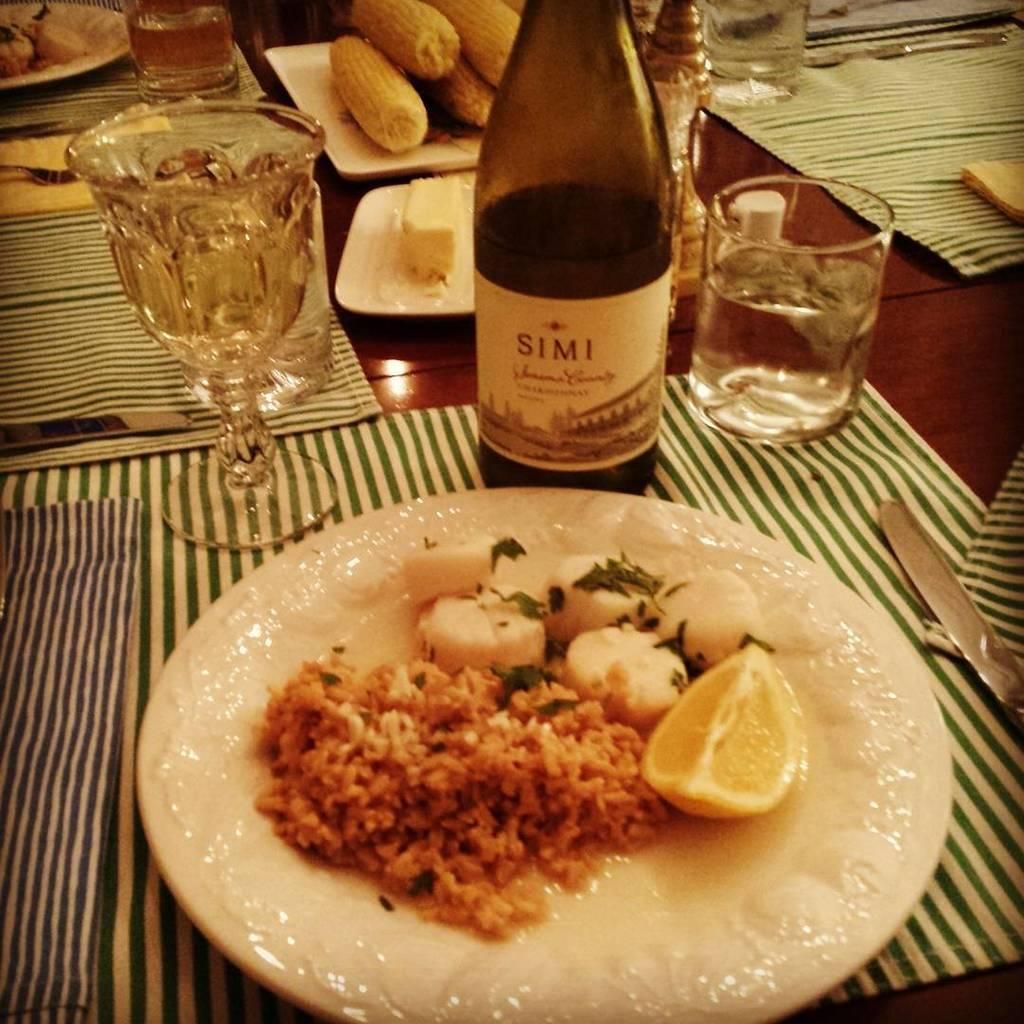<image>
Offer a succinct explanation of the picture presented. In front of a half empty bottle of Simi is a dinner plate containing rice, a lemon wedge, and sea scallops with a green garnish. 